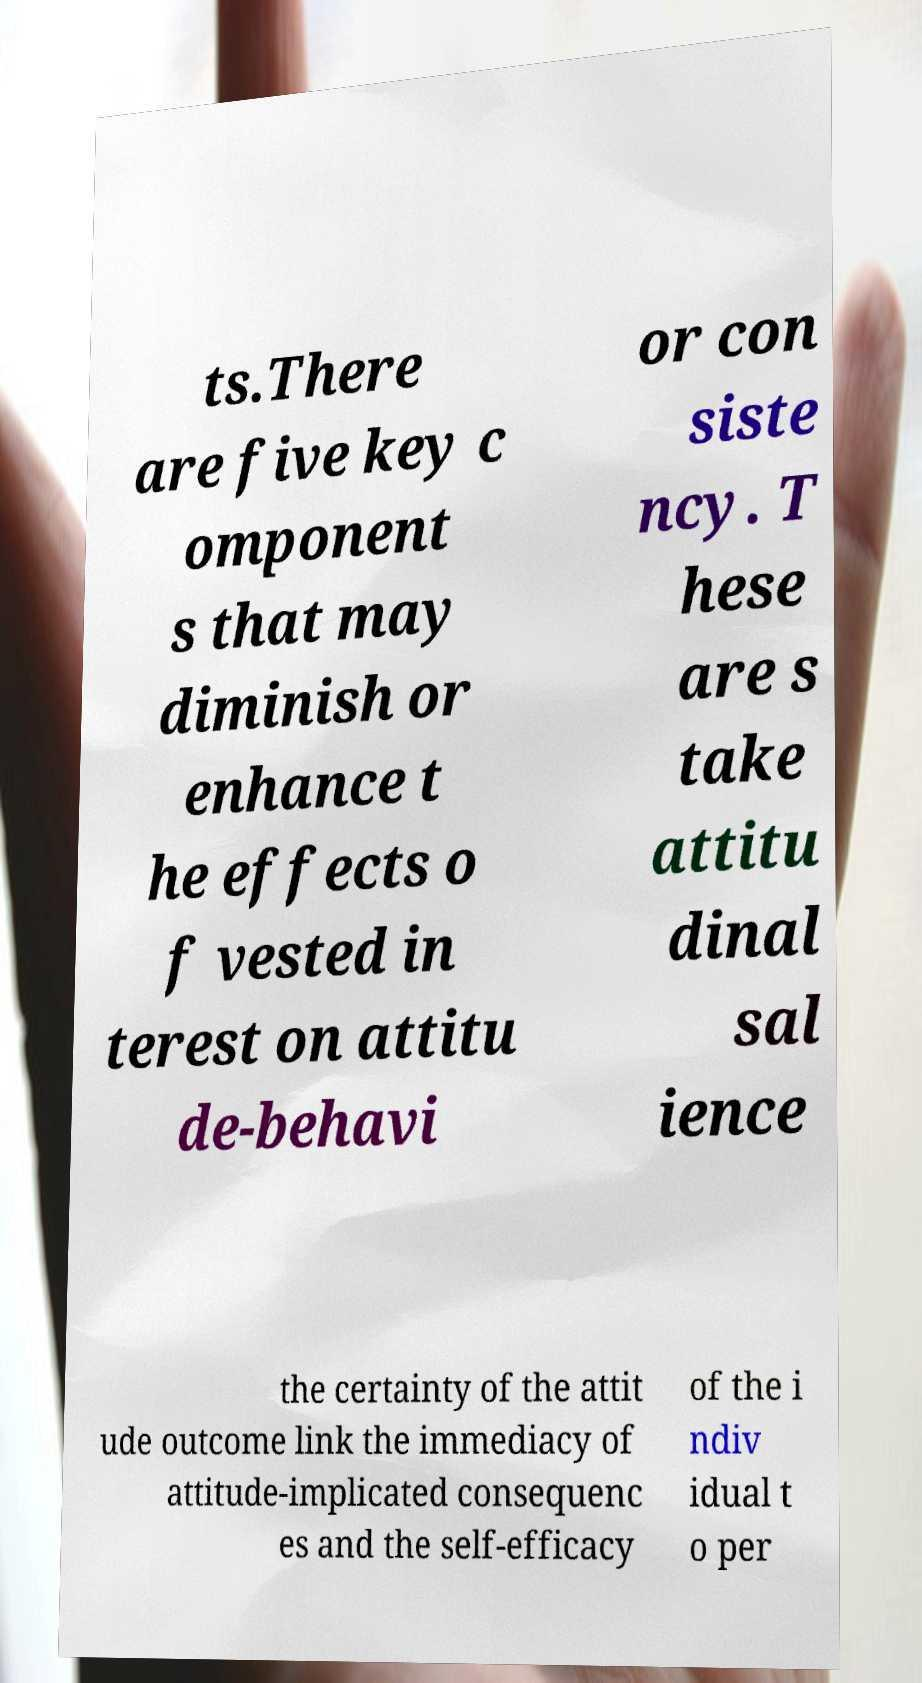Please read and relay the text visible in this image. What does it say? ts.There are five key c omponent s that may diminish or enhance t he effects o f vested in terest on attitu de-behavi or con siste ncy. T hese are s take attitu dinal sal ience the certainty of the attit ude outcome link the immediacy of attitude-implicated consequenc es and the self-efficacy of the i ndiv idual t o per 